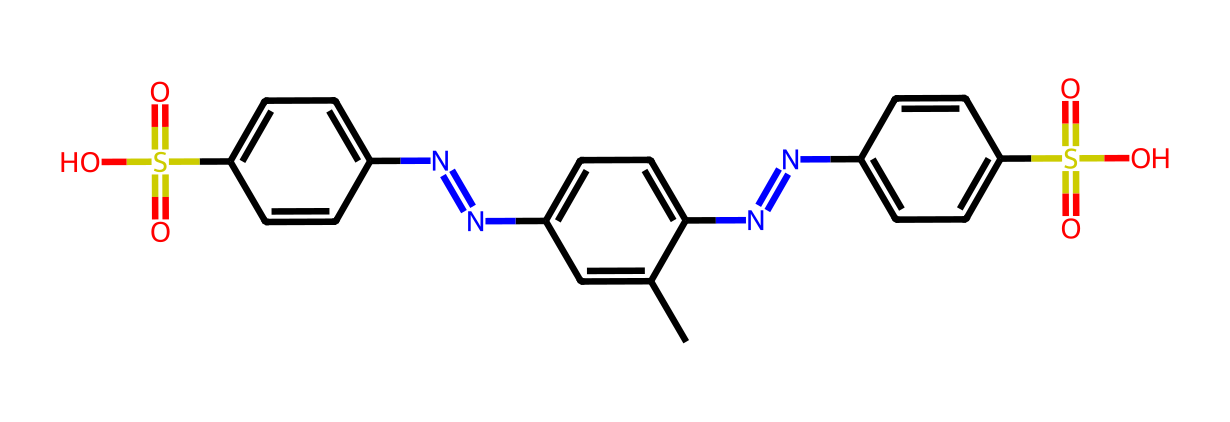what is the total number of nitrogen atoms in this chemical? The provided SMILES representation contains multiple 'N' characters, indicating nitrogen atoms. Upon counting, there are four 'N' characters in the structure.
Answer: four how many sulfur atoms are present in this chemical? Observing the SMILES representation, we find two 'S' characters, indicating two sulfur atoms.
Answer: two what are the types of functional groups present in this dye? Analyzing the structure, we identify sulfonic acid groups (S(=O)(=O)O) associated with the sulfur atoms, and there are nitrogen-containing groups (N=NC), indicating the presence of amines or amides.
Answer: sulfonic acid, amine does this dye contain aromatic rings? The presence of alternating single and double bonds in the cyclic structures alongside the 'C' atoms suggests the presence of aromatic rings in the chemical.
Answer: yes what role do the sulfonic acid groups play in textile manufacturing? Sulfonic acid groups, as seen in the structure, enhance the dye's solubility in water, allowing better penetration into textile fibers during the dyeing process, promoting even coloration.
Answer: improve solubility how many carbon atoms are in the chemical structure? By counting the 'C' characters in the SMILES, we find there are 18 carbon atoms present in the chemical structure.
Answer: eighteen give an example of how this type of dye might react to light. Photoreactive dyes often undergo structural changes or initiate photochemical reactions when exposed to light, which can result in color alteration or polymerization, utilized in photo-sensitive textile processes.
Answer: color alteration 